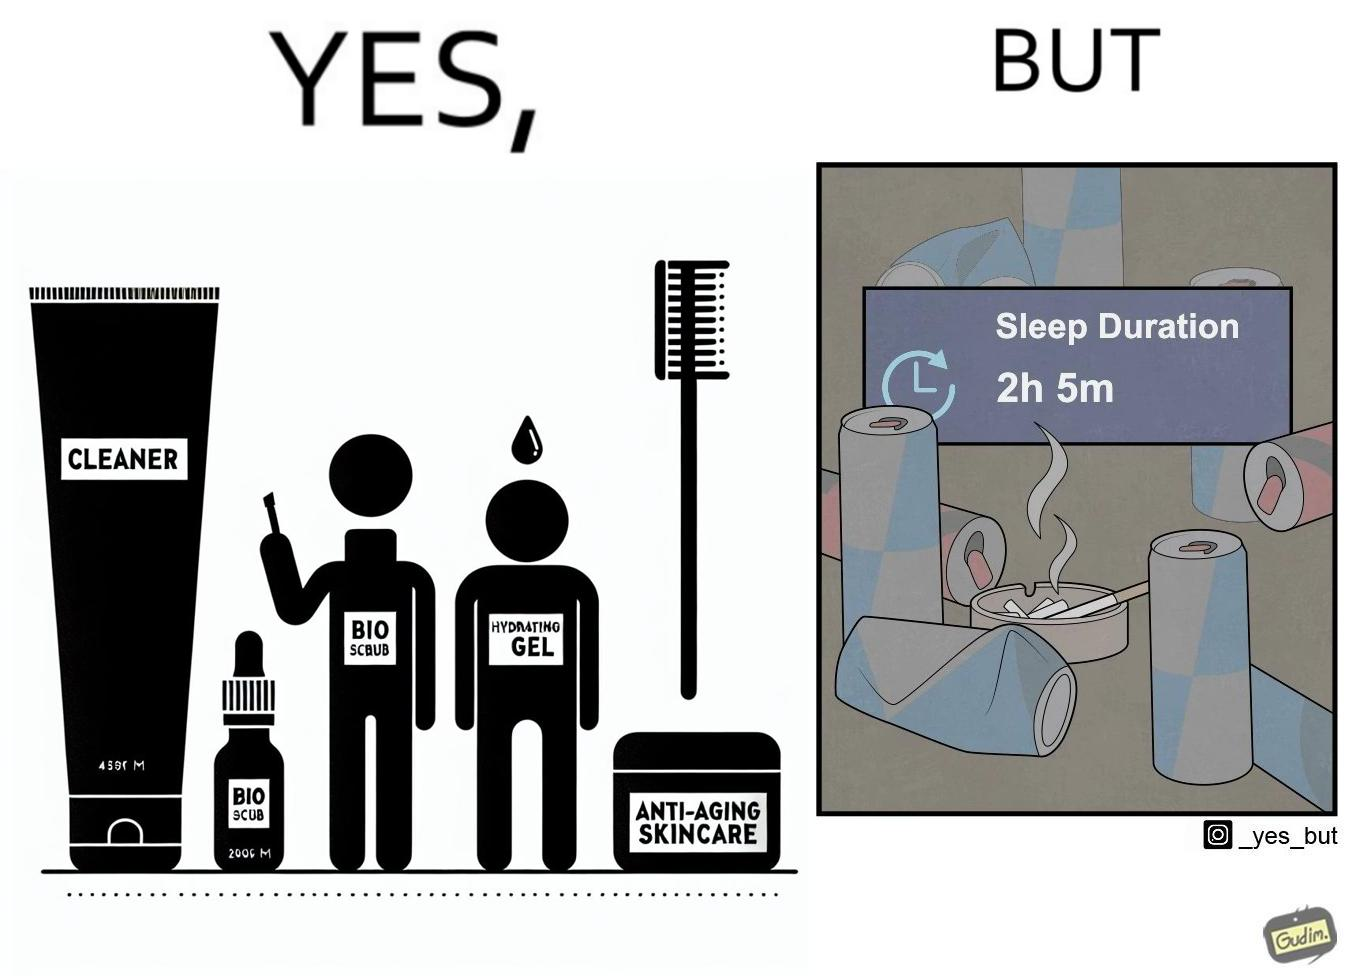Compare the left and right sides of this image. In the left part of the image: 4 Skincare products, arranged aesthetically. A tube labeled "Cleaner". A tube labeled "BIO SCRUB". A dropper bottle labeled "HYDRATING GEL". A jar called "ANTI-AGING SKINCARE". In the right part of the image: 9 cans of red bull, some standing upright, some crushed. Cans have blue and red colors. An ashtray with many cigarette butts in it and has smoke coming out. A banner that says "Sleep duration 2h 5min". 